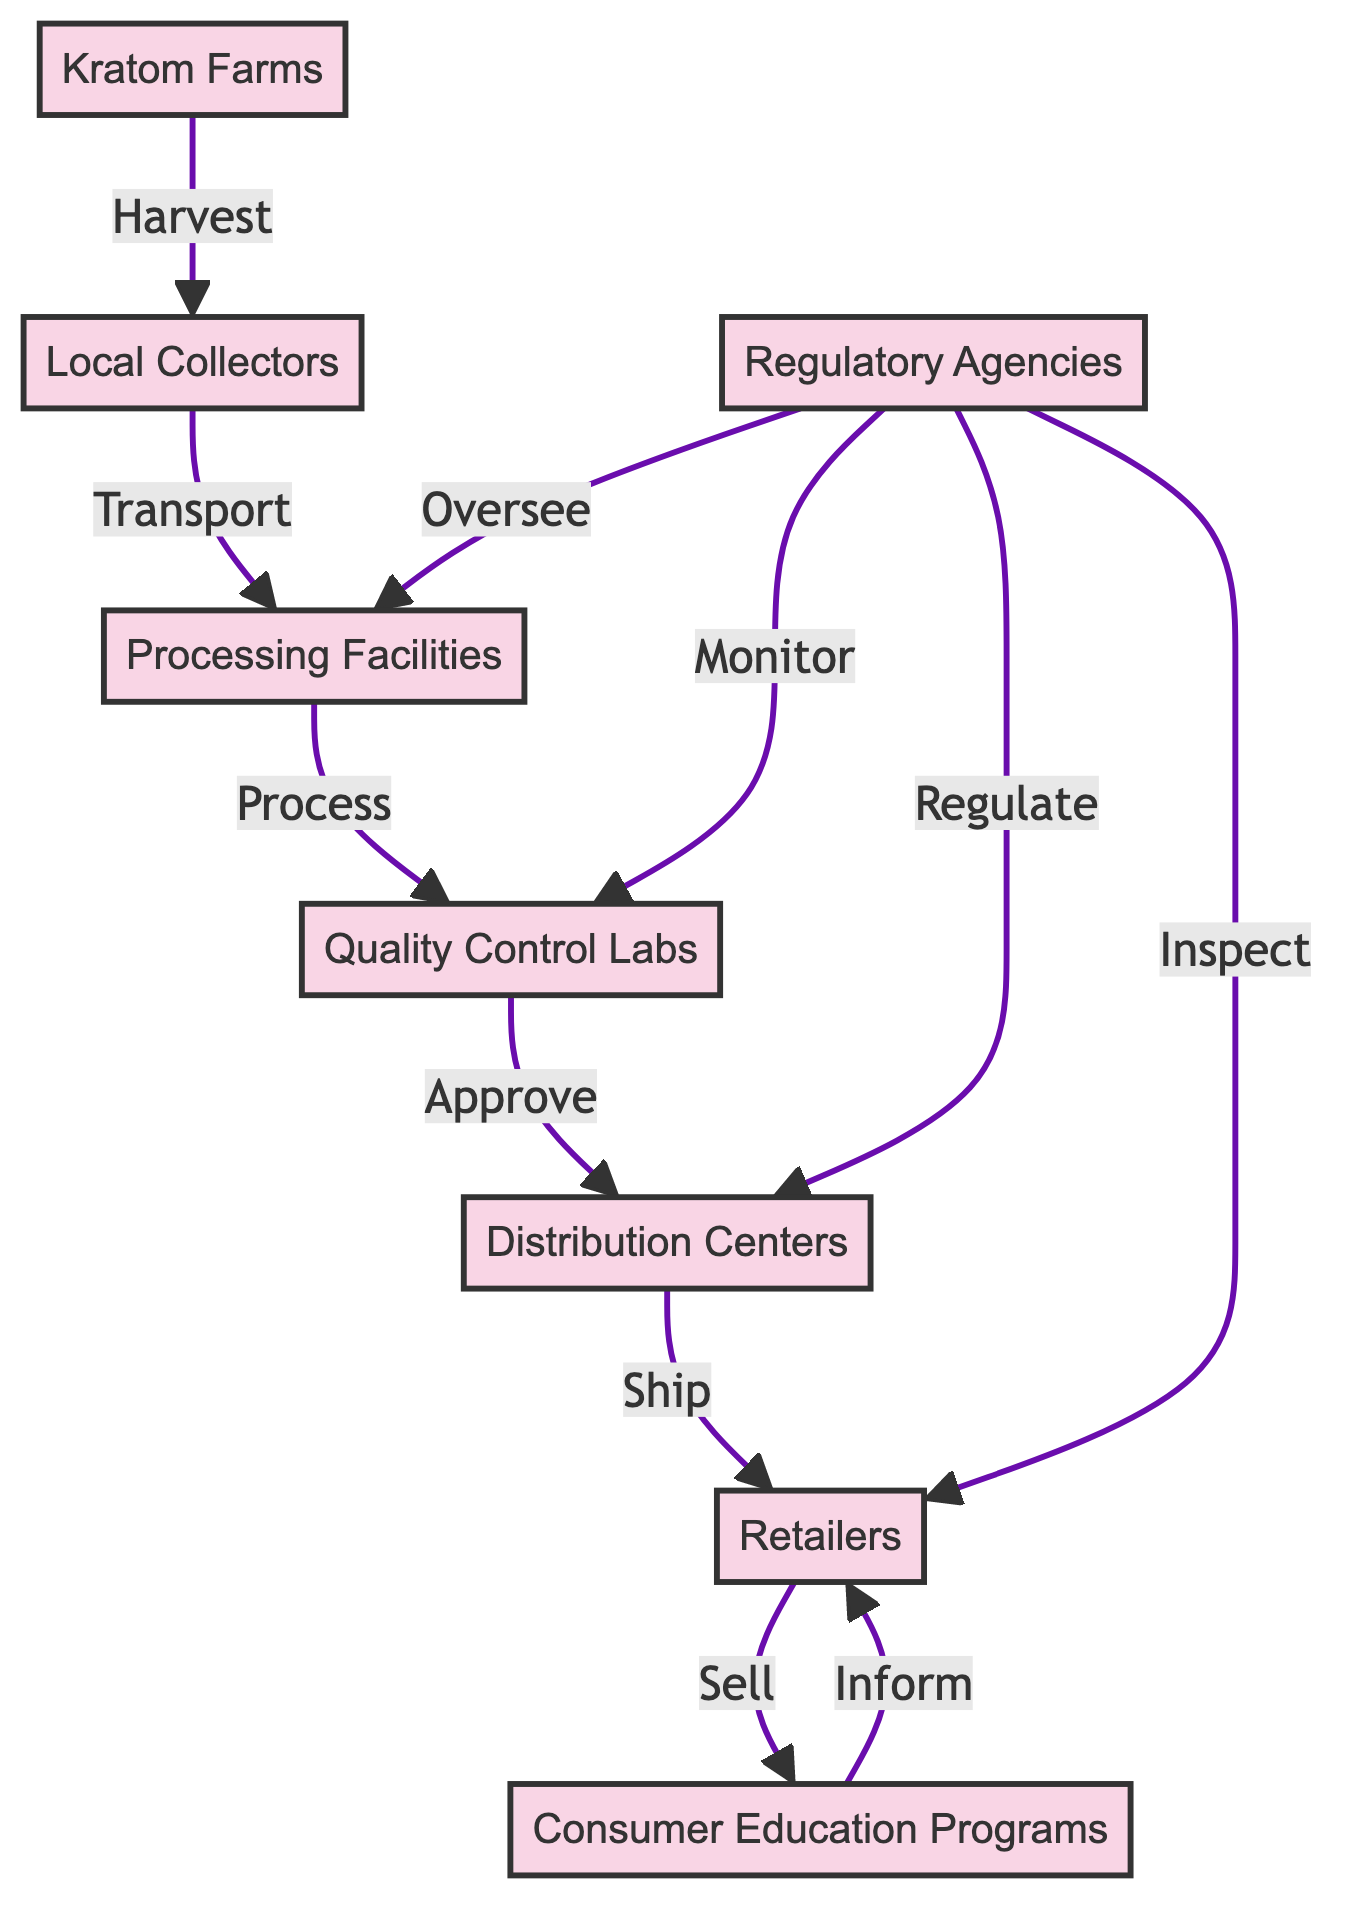What is the first node in the supply chain? The diagram shows that the flow starts from "Kratom Farms," which is the initial point where cultivation occurs.
Answer: Kratom Farms How many nodes are present in the diagram? By counting each unique element, there are a total of 8 nodes: Kratom Farms, Local Collectors, Processing Facilities, Quality Control Labs, Distribution Centers, Retailers, Regulatory Agencies, and Consumer Education Programs.
Answer: 8 Which node directly follows Processing Facilities? The immediate successor to "Processing Facilities" in the flow is "Quality Control Labs," meaning that processed kratom is subjected to testing directly afterward.
Answer: Quality Control Labs What relationship exists between Regulatory Agencies and Quality Control Labs? The relationship indicates that "Regulatory Agencies" are responsible for overseeing and monitoring the "Quality Control Labs," ensuring compliance with standards.
Answer: Monitor How many edges connect Kratom Farms to Retailers directly? The diagram shows that "Kratom Farms" connects to "Retailers" indirectly through several other nodes, so the count of direct edges from Kratom Farms to Retailers is zero.
Answer: 0 What role do Distribution Centers play in the supply chain? Distribution Centers act as storage points where finished kratom products are held before being shipped, serving as a logistical hub in the supply chain.
Answer: Ship What action is taken by Local Collectors? Local Collectors have the specific task of collecting harvested kratom leaves from the farms and transporting them to the processing facilities.
Answer: Transport Which node has a direct link to Consumer Education Programs? The node that has a direct link to "Consumer Education Programs" is "Retailers," indicating that retailers are involved in educating consumers about kratom products.
Answer: Retailers What type of oversight do Regulatory Agencies provide regarding Distribution Centers? Regulatory Agencies provide regulation over "Distribution Centers," ensuring that the kratom products are compliant with legal standards before they reach consumers.
Answer: Regulate How does Quality Control Labs affect the flow of products? The role of "Quality Control Labs" is critical as it affects the flow by approving the processed products before they can move on to Distribution Centers, acting as a quality checkpoint.
Answer: Approve 